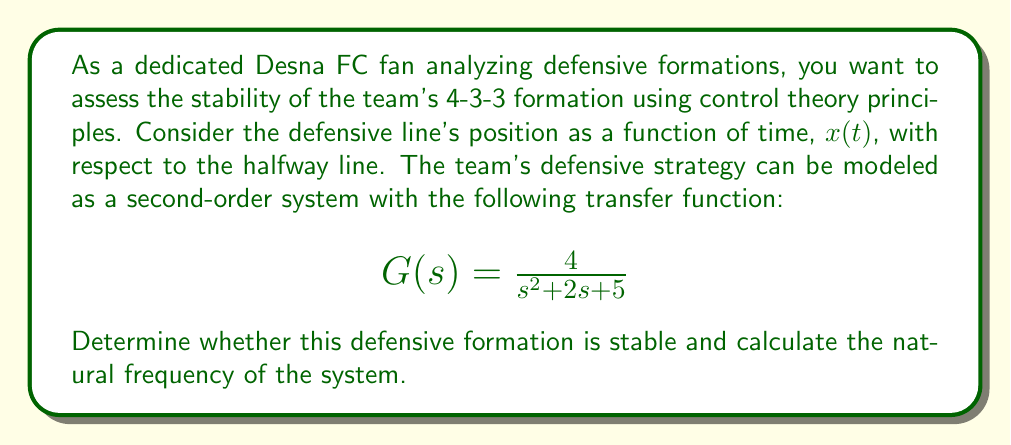Teach me how to tackle this problem. To analyze the stability of the defensive formation and calculate the natural frequency, we'll follow these steps:

1. Stability analysis:
   To determine stability, we need to examine the characteristic equation of the system. The characteristic equation is the denominator of the transfer function set equal to zero:

   $$s^2 + 2s + 5 = 0$$

   We can factor this equation or use the quadratic formula to find its roots:

   $$s = \frac{-2 \pm \sqrt{2^2 - 4(1)(5)}}{2(1)} = \frac{-2 \pm \sqrt{4 - 20}}{2} = \frac{-2 \pm \sqrt{-16}}{2} = -1 \pm 2j$$

   The roots of the characteristic equation are the poles of the system. For a system to be stable, all poles must have negative real parts. In this case, both poles have a real part of -1, which is negative.

2. Natural frequency calculation:
   The natural frequency ($\omega_n$) of a second-order system is given by the square root of the constant term in the characteristic equation. In this case:

   $$\omega_n = \sqrt{5}$$

   We can also verify this by comparing our transfer function to the standard form of a second-order system:

   $$G(s) = \frac{\omega_n^2}{s^2 + 2\zeta\omega_n s + \omega_n^2}$$

   Where $\zeta$ is the damping ratio and $\omega_n$ is the natural frequency.

   Comparing our transfer function to this standard form:

   $$\frac{4}{s^2 + 2s + 5} = \frac{4}{\frac{5}{5}s^2 + \frac{2}{5}5s + 5} = \frac{\frac{4}{5}}{\frac{1}{5}(s^2 + 2s + 5)}$$

   This confirms that $\omega_n^2 = 5$, and therefore $\omega_n = \sqrt{5}$.
Answer: The defensive formation is stable, as both poles have negative real parts (-1 ± 2j). The natural frequency of the system is $\omega_n = \sqrt{5}$ rad/s. 